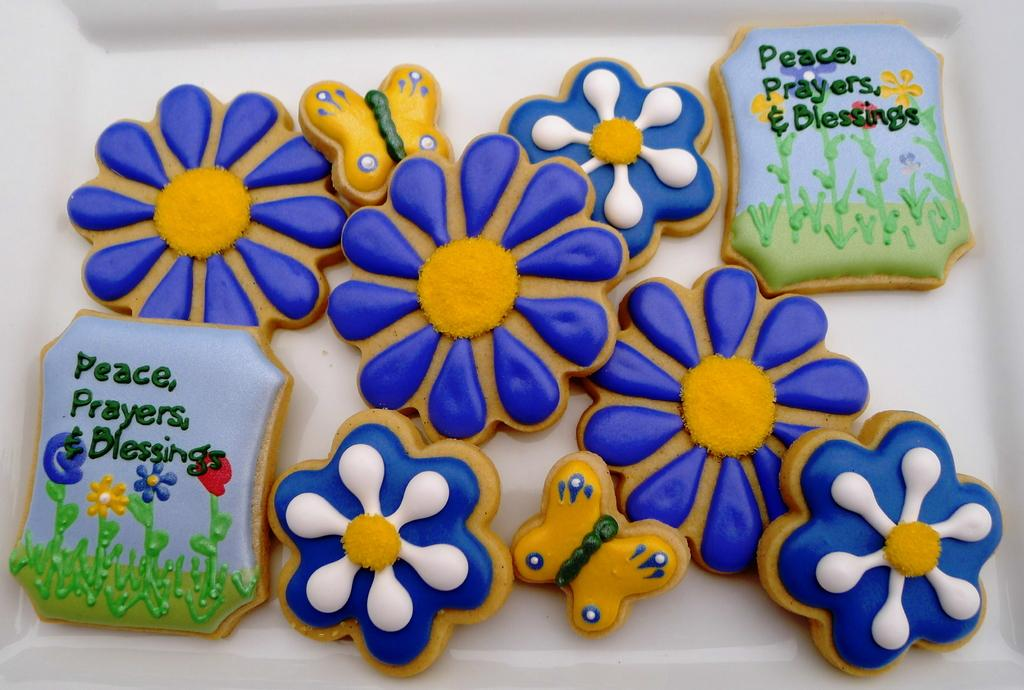What type of flowers are present in the image? There are plastic blue color flowers in the image. What other living creatures can be seen in the image? There are yellow color butterflies in the image. Is there any text or writing in the image? Yes, there is something written in the image. How many police officers are visible in the image? There are no police officers present in the image. Can you fold the dust in the image? There is no dust present in the image, so it cannot be folded. 